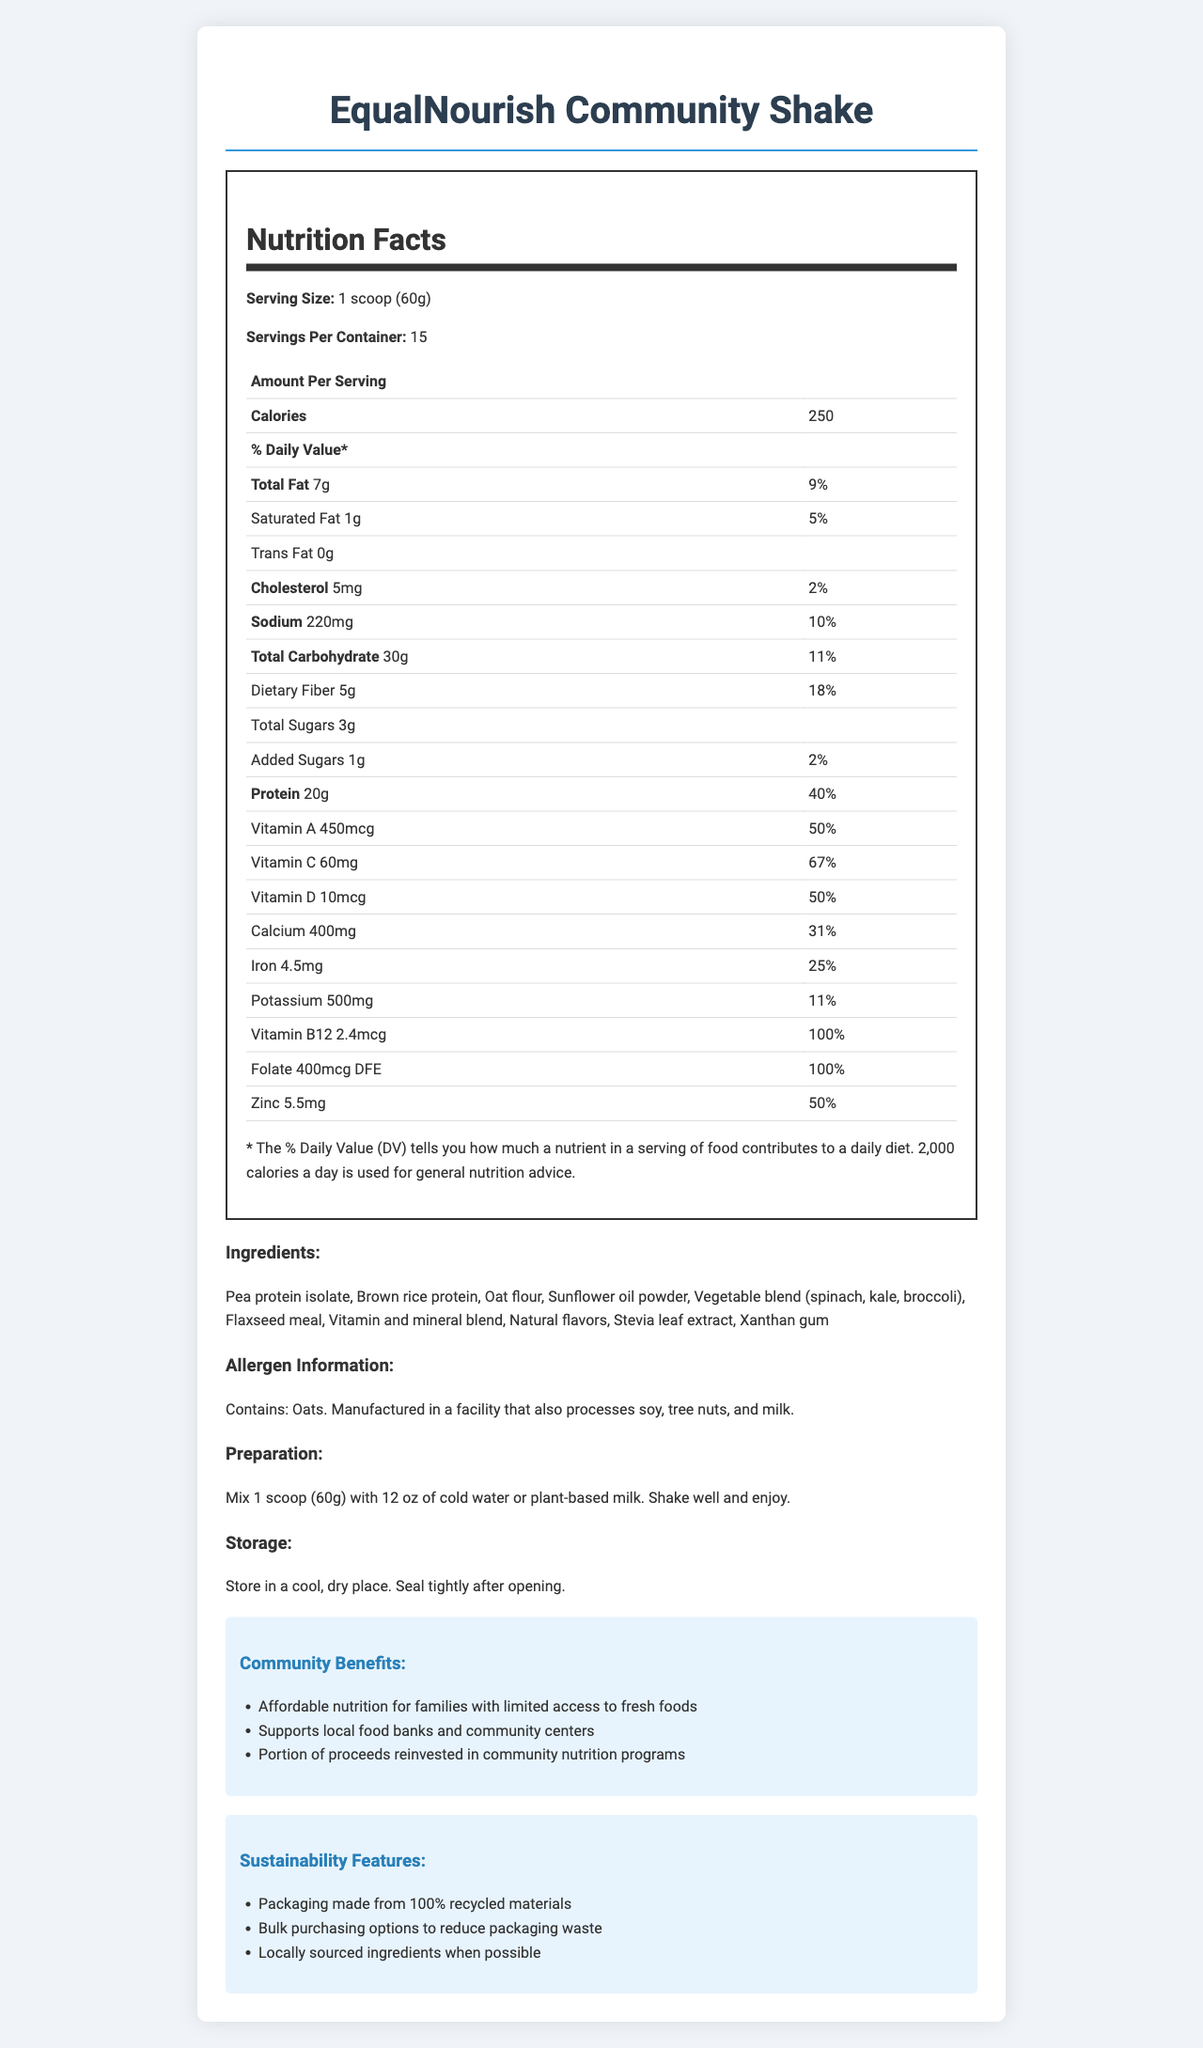what is the serving size? The serving size is explicitly mentioned as "1 scoop (60g)" in the nutrition label section of the document.
Answer: 1 scoop (60g) how many calories are in one serving? The number of calories per serving is stated as "250" in the nutrition label section of the document.
Answer: 250 list three main ingredients in EqualNourish Community Shake. These ingredients are listed under the "Ingredients" section of the document.
Answer: Pea protein isolate, Brown rice protein, Oat flour how much dietary fiber is in one serving? The document states that each serving contains "Dietary Fiber 5g" in the nutrition label.
Answer: 5g what is the percentage of daily value for protein per serving? The document lists "Protein" and its daily value as "40%" in the nutrition label.
Answer: 40% what is the total amount of sugars per serving, including added sugars? A. 1g B. 3g C. 4g D. 5g The document states that the total sugars per serving is "Total Sugars 3g".
Answer: B. 3g which of the following vitamins are present in a serving of EqualNourish Community Shake? I. Vitamin A II. Vitamin C III. Vitamin E IV. Vitamin K The document lists "Vitamin A" and "Vitamin C" with their respective amounts, but there is no mention of "Vitamin E" or "Vitamin K".
Answer: I and II does the shake contain trans fat? The document explicitly mentions "Trans Fat 0g" under the nutrition label.
Answer: No does this product contain any allergens? The document states, "Contains: Oats" under the "Allergen Information" section.
Answer: Yes summarize the main purpose of EqualNourish Community Shake. The document's purpose is explained through various sections, including community benefits, sustainability features, and nutritional information, indicating its role in providing affordable nutrition and community support.
Answer: EqualNourish Community Shake is a cost-effective, nutrient-dense meal replacement designed for community members with limited access to fresh foods. It offers essential nutrients to support overall health and includes community benefits such as supporting local food banks and reinvesting in community nutrition programs. The shake also emphasizes sustainability with recycled packaging and locally sourced ingredients when possible. what are the sustainability features of the packaging? Based on the visual document, specific sustainability features of the packaging are not detailed other than the general statement that it is made from 100% recycled materials.
Answer: Cannot be determined 